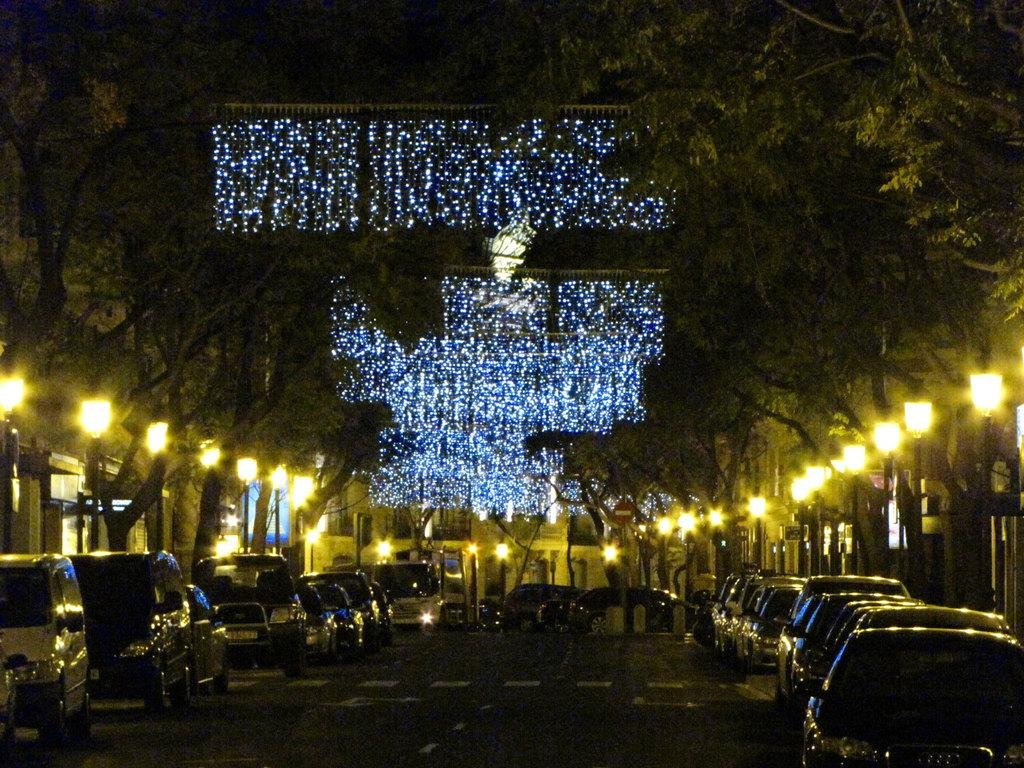What is the main feature of the image? There is a road in the image. What else can be seen on the road? There are vehicles in the image. What other elements are present in the image besides the road and vehicles? There are lights, trees, and buildings in the image. How many brothers are depicted in the image? There are no people or figures in the image, so it is not possible to determine the number of brothers. What type of substance is being used to create the lights in the image? There is no information about the materials or substances used to create the lights in the image. 